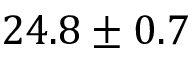Convert formula to latex. <formula><loc_0><loc_0><loc_500><loc_500>2 4 . 8 \pm 0 . 7</formula> 